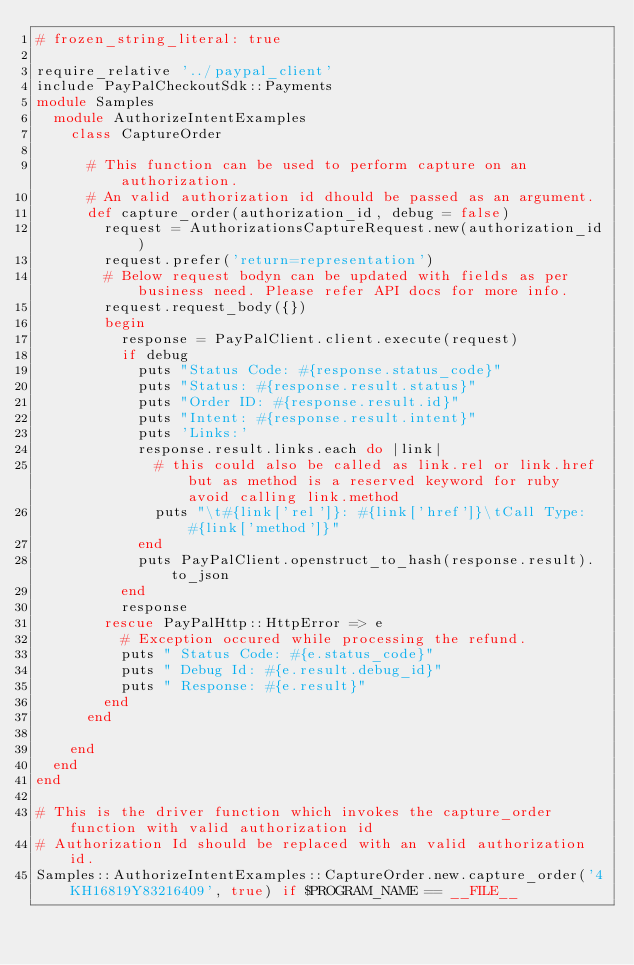Convert code to text. <code><loc_0><loc_0><loc_500><loc_500><_Ruby_># frozen_string_literal: true

require_relative '../paypal_client'
include PayPalCheckoutSdk::Payments
module Samples
  module AuthorizeIntentExamples
    class CaptureOrder

      # This function can be used to perform capture on an authorization.
      # An valid authorization id dhould be passed as an argument.
      def capture_order(authorization_id, debug = false)
        request = AuthorizationsCaptureRequest.new(authorization_id)
        request.prefer('return=representation')
        # Below request bodyn can be updated with fields as per business need. Please refer API docs for more info.
        request.request_body({})
        begin
          response = PayPalClient.client.execute(request)
          if debug
            puts "Status Code: #{response.status_code}"
            puts "Status: #{response.result.status}"
            puts "Order ID: #{response.result.id}"
            puts "Intent: #{response.result.intent}"
            puts 'Links:'
            response.result.links.each do |link|
              # this could also be called as link.rel or link.href but as method is a reserved keyword for ruby avoid calling link.method
              puts "\t#{link['rel']}: #{link['href']}\tCall Type: #{link['method']}"
            end
            puts PayPalClient.openstruct_to_hash(response.result).to_json
          end
          response
        rescue PayPalHttp::HttpError => e
          # Exception occured while processing the refund.
          puts " Status Code: #{e.status_code}"
          puts " Debug Id: #{e.result.debug_id}"
          puts " Response: #{e.result}"
        end
      end

    end
  end
end

# This is the driver function which invokes the capture_order function with valid authorization id
# Authorization Id should be replaced with an valid authorization id.
Samples::AuthorizeIntentExamples::CaptureOrder.new.capture_order('4KH16819Y83216409', true) if $PROGRAM_NAME == __FILE__
</code> 